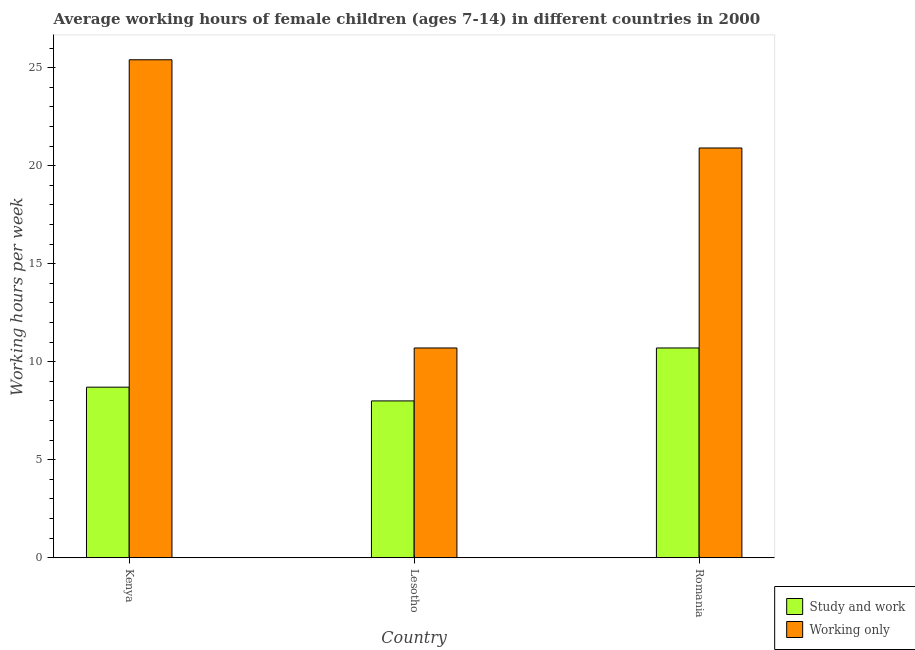How many different coloured bars are there?
Provide a short and direct response. 2. How many groups of bars are there?
Your answer should be very brief. 3. Are the number of bars on each tick of the X-axis equal?
Your response must be concise. Yes. How many bars are there on the 2nd tick from the left?
Provide a short and direct response. 2. How many bars are there on the 1st tick from the right?
Your answer should be very brief. 2. What is the label of the 1st group of bars from the left?
Make the answer very short. Kenya. In how many cases, is the number of bars for a given country not equal to the number of legend labels?
Make the answer very short. 0. What is the average working hour of children involved in only work in Romania?
Give a very brief answer. 20.9. Across all countries, what is the maximum average working hour of children involved in only work?
Offer a very short reply. 25.4. Across all countries, what is the minimum average working hour of children involved in study and work?
Your answer should be very brief. 8. In which country was the average working hour of children involved in only work maximum?
Ensure brevity in your answer.  Kenya. In which country was the average working hour of children involved in study and work minimum?
Your answer should be very brief. Lesotho. What is the total average working hour of children involved in study and work in the graph?
Offer a very short reply. 27.4. What is the difference between the average working hour of children involved in study and work in Lesotho and that in Romania?
Your response must be concise. -2.7. What is the difference between the average working hour of children involved in study and work in Lesotho and the average working hour of children involved in only work in Romania?
Keep it short and to the point. -12.9. What is the average average working hour of children involved in study and work per country?
Keep it short and to the point. 9.13. What is the difference between the average working hour of children involved in study and work and average working hour of children involved in only work in Romania?
Ensure brevity in your answer.  -10.2. What is the ratio of the average working hour of children involved in study and work in Lesotho to that in Romania?
Make the answer very short. 0.75. Is the average working hour of children involved in study and work in Lesotho less than that in Romania?
Provide a short and direct response. Yes. Is the difference between the average working hour of children involved in only work in Kenya and Romania greater than the difference between the average working hour of children involved in study and work in Kenya and Romania?
Provide a short and direct response. Yes. What is the difference between the highest and the second highest average working hour of children involved in only work?
Ensure brevity in your answer.  4.5. In how many countries, is the average working hour of children involved in only work greater than the average average working hour of children involved in only work taken over all countries?
Give a very brief answer. 2. Is the sum of the average working hour of children involved in study and work in Lesotho and Romania greater than the maximum average working hour of children involved in only work across all countries?
Keep it short and to the point. No. What does the 1st bar from the left in Romania represents?
Ensure brevity in your answer.  Study and work. What does the 1st bar from the right in Romania represents?
Offer a very short reply. Working only. Are all the bars in the graph horizontal?
Give a very brief answer. No. How many countries are there in the graph?
Your answer should be compact. 3. Does the graph contain any zero values?
Provide a succinct answer. No. Does the graph contain grids?
Offer a very short reply. No. Where does the legend appear in the graph?
Your answer should be compact. Bottom right. How many legend labels are there?
Ensure brevity in your answer.  2. How are the legend labels stacked?
Ensure brevity in your answer.  Vertical. What is the title of the graph?
Provide a short and direct response. Average working hours of female children (ages 7-14) in different countries in 2000. Does "Male population" appear as one of the legend labels in the graph?
Give a very brief answer. No. What is the label or title of the Y-axis?
Your response must be concise. Working hours per week. What is the Working hours per week of Study and work in Kenya?
Your answer should be compact. 8.7. What is the Working hours per week of Working only in Kenya?
Provide a short and direct response. 25.4. What is the Working hours per week of Study and work in Lesotho?
Ensure brevity in your answer.  8. What is the Working hours per week of Working only in Lesotho?
Ensure brevity in your answer.  10.7. What is the Working hours per week of Study and work in Romania?
Offer a terse response. 10.7. What is the Working hours per week of Working only in Romania?
Your answer should be very brief. 20.9. Across all countries, what is the maximum Working hours per week of Study and work?
Your answer should be very brief. 10.7. Across all countries, what is the maximum Working hours per week of Working only?
Your response must be concise. 25.4. Across all countries, what is the minimum Working hours per week in Study and work?
Your answer should be very brief. 8. What is the total Working hours per week of Study and work in the graph?
Provide a succinct answer. 27.4. What is the total Working hours per week in Working only in the graph?
Provide a succinct answer. 57. What is the difference between the Working hours per week in Study and work in Kenya and that in Lesotho?
Your answer should be very brief. 0.7. What is the difference between the Working hours per week in Working only in Kenya and that in Lesotho?
Provide a succinct answer. 14.7. What is the difference between the Working hours per week in Study and work in Lesotho and that in Romania?
Your response must be concise. -2.7. What is the difference between the Working hours per week of Study and work in Kenya and the Working hours per week of Working only in Lesotho?
Provide a short and direct response. -2. What is the difference between the Working hours per week of Study and work in Kenya and the Working hours per week of Working only in Romania?
Keep it short and to the point. -12.2. What is the average Working hours per week in Study and work per country?
Keep it short and to the point. 9.13. What is the difference between the Working hours per week of Study and work and Working hours per week of Working only in Kenya?
Your answer should be very brief. -16.7. What is the difference between the Working hours per week in Study and work and Working hours per week in Working only in Lesotho?
Ensure brevity in your answer.  -2.7. What is the ratio of the Working hours per week in Study and work in Kenya to that in Lesotho?
Provide a short and direct response. 1.09. What is the ratio of the Working hours per week of Working only in Kenya to that in Lesotho?
Ensure brevity in your answer.  2.37. What is the ratio of the Working hours per week in Study and work in Kenya to that in Romania?
Your answer should be very brief. 0.81. What is the ratio of the Working hours per week of Working only in Kenya to that in Romania?
Your answer should be very brief. 1.22. What is the ratio of the Working hours per week of Study and work in Lesotho to that in Romania?
Offer a very short reply. 0.75. What is the ratio of the Working hours per week of Working only in Lesotho to that in Romania?
Provide a short and direct response. 0.51. What is the difference between the highest and the second highest Working hours per week of Working only?
Ensure brevity in your answer.  4.5. What is the difference between the highest and the lowest Working hours per week in Working only?
Your answer should be very brief. 14.7. 